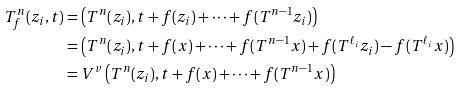<formula> <loc_0><loc_0><loc_500><loc_500>T _ { f } ^ { n } ( z _ { i } , t ) & = \left ( T ^ { n } ( z _ { i } ) , t + f ( z _ { i } ) + \cdots + f ( T ^ { n - 1 } z _ { i } ) \right ) \\ & = \left ( T ^ { n } ( z _ { i } ) , t + f ( x ) + \cdots + f ( T ^ { n - 1 } x ) + f ( T ^ { \ell _ { i } } z _ { i } ) - f ( T ^ { \ell _ { i } } x ) \right ) \\ & = V ^ { v } \left ( T ^ { n } ( z _ { i } ) , t + f ( x ) + \cdots + f ( T ^ { n - 1 } x ) \right )</formula> 